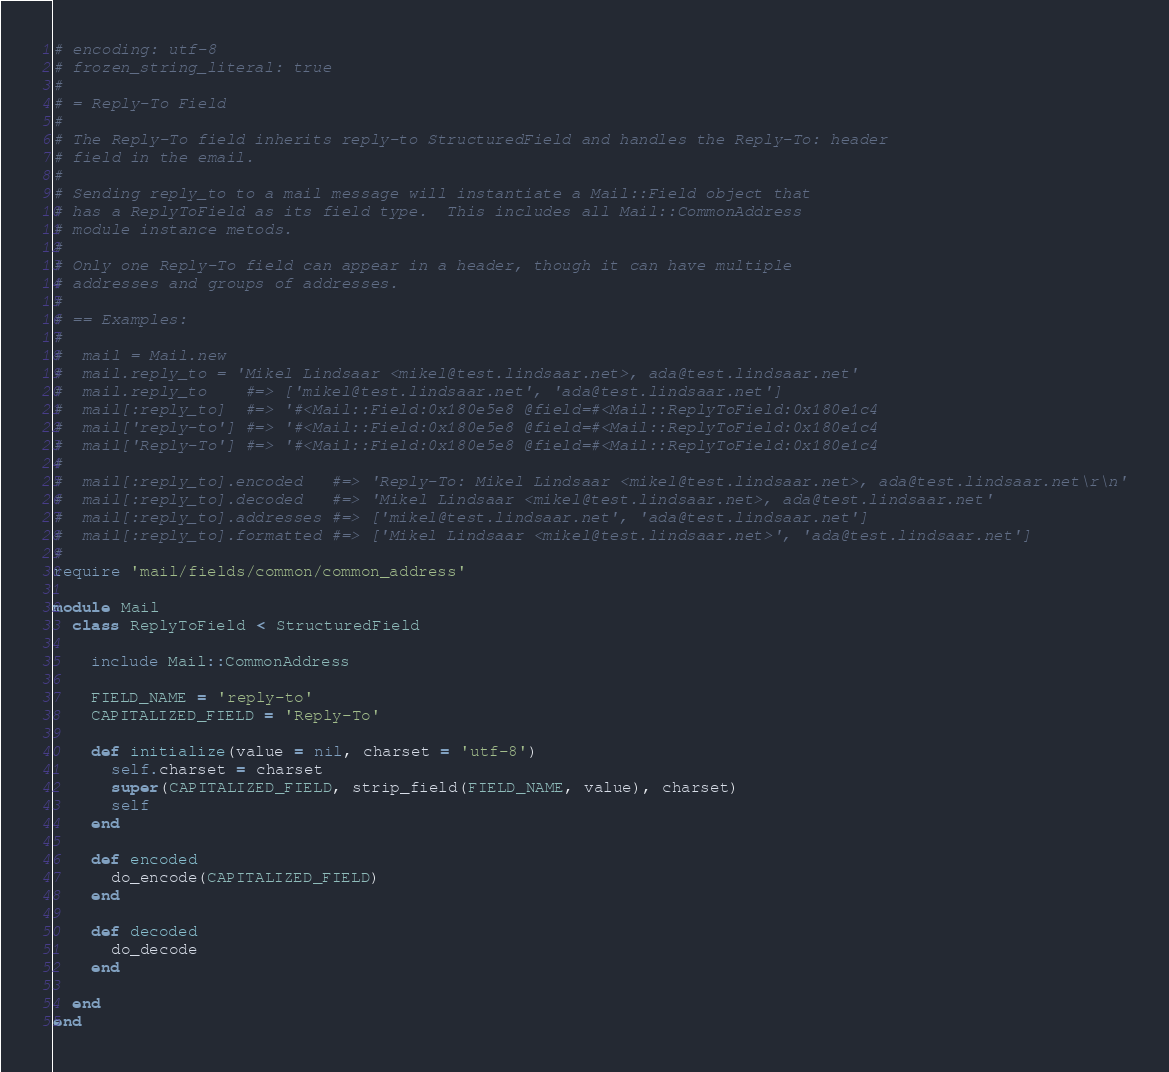<code> <loc_0><loc_0><loc_500><loc_500><_Ruby_># encoding: utf-8
# frozen_string_literal: true
# 
# = Reply-To Field
# 
# The Reply-To field inherits reply-to StructuredField and handles the Reply-To: header
# field in the email.
# 
# Sending reply_to to a mail message will instantiate a Mail::Field object that
# has a ReplyToField as its field type.  This includes all Mail::CommonAddress
# module instance metods.
# 
# Only one Reply-To field can appear in a header, though it can have multiple
# addresses and groups of addresses.
# 
# == Examples:
# 
#  mail = Mail.new
#  mail.reply_to = 'Mikel Lindsaar <mikel@test.lindsaar.net>, ada@test.lindsaar.net'
#  mail.reply_to    #=> ['mikel@test.lindsaar.net', 'ada@test.lindsaar.net']
#  mail[:reply_to]  #=> '#<Mail::Field:0x180e5e8 @field=#<Mail::ReplyToField:0x180e1c4
#  mail['reply-to'] #=> '#<Mail::Field:0x180e5e8 @field=#<Mail::ReplyToField:0x180e1c4
#  mail['Reply-To'] #=> '#<Mail::Field:0x180e5e8 @field=#<Mail::ReplyToField:0x180e1c4
# 
#  mail[:reply_to].encoded   #=> 'Reply-To: Mikel Lindsaar <mikel@test.lindsaar.net>, ada@test.lindsaar.net\r\n'
#  mail[:reply_to].decoded   #=> 'Mikel Lindsaar <mikel@test.lindsaar.net>, ada@test.lindsaar.net'
#  mail[:reply_to].addresses #=> ['mikel@test.lindsaar.net', 'ada@test.lindsaar.net']
#  mail[:reply_to].formatted #=> ['Mikel Lindsaar <mikel@test.lindsaar.net>', 'ada@test.lindsaar.net']
# 
require 'mail/fields/common/common_address'

module Mail
  class ReplyToField < StructuredField
    
    include Mail::CommonAddress
    
    FIELD_NAME = 'reply-to'
    CAPITALIZED_FIELD = 'Reply-To'
    
    def initialize(value = nil, charset = 'utf-8')
      self.charset = charset
      super(CAPITALIZED_FIELD, strip_field(FIELD_NAME, value), charset)
      self
    end
    
    def encoded
      do_encode(CAPITALIZED_FIELD)
    end
    
    def decoded
      do_decode
    end
    
  end
end
</code> 